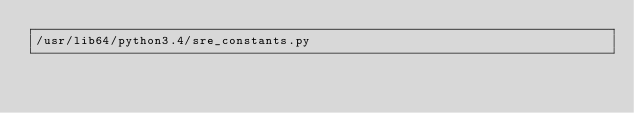<code> <loc_0><loc_0><loc_500><loc_500><_Python_>/usr/lib64/python3.4/sre_constants.py</code> 